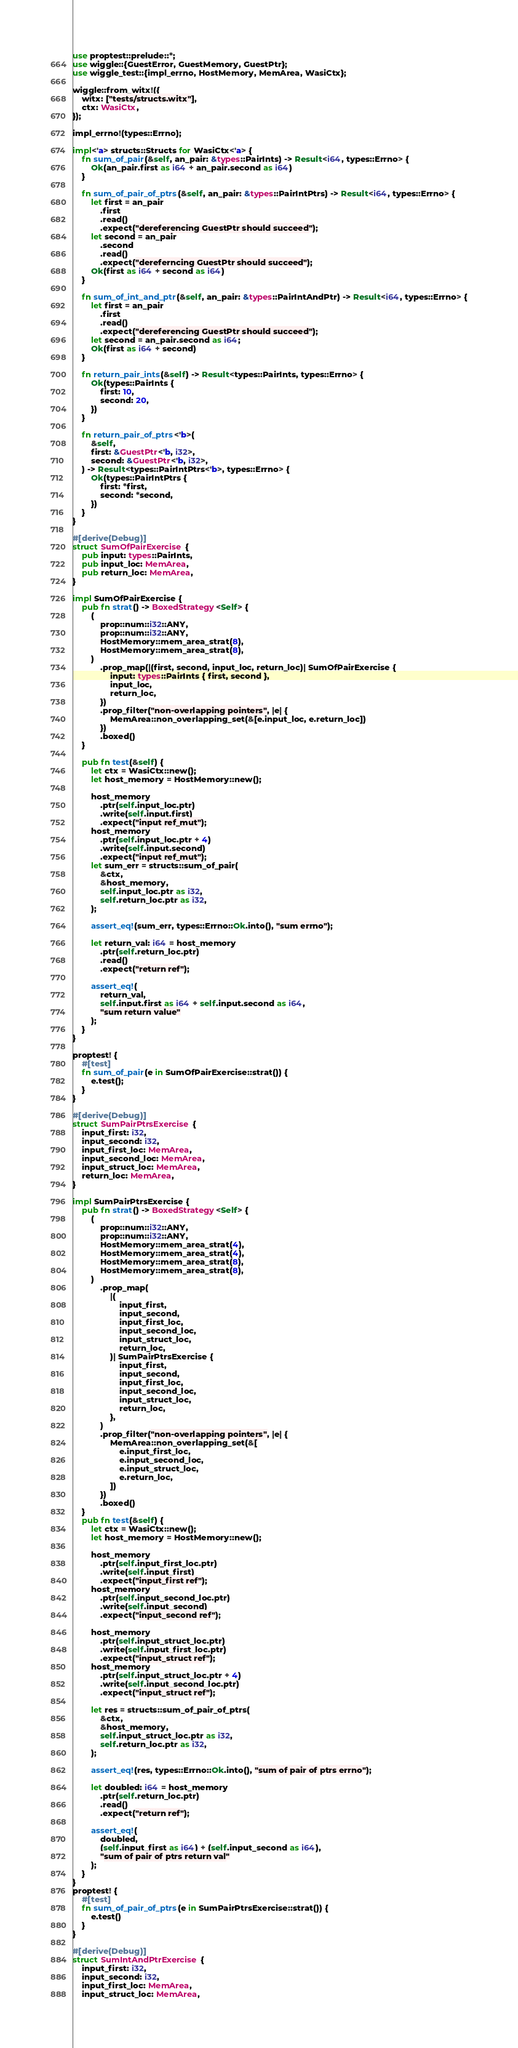Convert code to text. <code><loc_0><loc_0><loc_500><loc_500><_Rust_>use proptest::prelude::*;
use wiggle::{GuestError, GuestMemory, GuestPtr};
use wiggle_test::{impl_errno, HostMemory, MemArea, WasiCtx};

wiggle::from_witx!({
    witx: ["tests/structs.witx"],
    ctx: WasiCtx,
});

impl_errno!(types::Errno);

impl<'a> structs::Structs for WasiCtx<'a> {
    fn sum_of_pair(&self, an_pair: &types::PairInts) -> Result<i64, types::Errno> {
        Ok(an_pair.first as i64 + an_pair.second as i64)
    }

    fn sum_of_pair_of_ptrs(&self, an_pair: &types::PairIntPtrs) -> Result<i64, types::Errno> {
        let first = an_pair
            .first
            .read()
            .expect("dereferencing GuestPtr should succeed");
        let second = an_pair
            .second
            .read()
            .expect("dereferncing GuestPtr should succeed");
        Ok(first as i64 + second as i64)
    }

    fn sum_of_int_and_ptr(&self, an_pair: &types::PairIntAndPtr) -> Result<i64, types::Errno> {
        let first = an_pair
            .first
            .read()
            .expect("dereferencing GuestPtr should succeed");
        let second = an_pair.second as i64;
        Ok(first as i64 + second)
    }

    fn return_pair_ints(&self) -> Result<types::PairInts, types::Errno> {
        Ok(types::PairInts {
            first: 10,
            second: 20,
        })
    }

    fn return_pair_of_ptrs<'b>(
        &self,
        first: &GuestPtr<'b, i32>,
        second: &GuestPtr<'b, i32>,
    ) -> Result<types::PairIntPtrs<'b>, types::Errno> {
        Ok(types::PairIntPtrs {
            first: *first,
            second: *second,
        })
    }
}

#[derive(Debug)]
struct SumOfPairExercise {
    pub input: types::PairInts,
    pub input_loc: MemArea,
    pub return_loc: MemArea,
}

impl SumOfPairExercise {
    pub fn strat() -> BoxedStrategy<Self> {
        (
            prop::num::i32::ANY,
            prop::num::i32::ANY,
            HostMemory::mem_area_strat(8),
            HostMemory::mem_area_strat(8),
        )
            .prop_map(|(first, second, input_loc, return_loc)| SumOfPairExercise {
                input: types::PairInts { first, second },
                input_loc,
                return_loc,
            })
            .prop_filter("non-overlapping pointers", |e| {
                MemArea::non_overlapping_set(&[e.input_loc, e.return_loc])
            })
            .boxed()
    }

    pub fn test(&self) {
        let ctx = WasiCtx::new();
        let host_memory = HostMemory::new();

        host_memory
            .ptr(self.input_loc.ptr)
            .write(self.input.first)
            .expect("input ref_mut");
        host_memory
            .ptr(self.input_loc.ptr + 4)
            .write(self.input.second)
            .expect("input ref_mut");
        let sum_err = structs::sum_of_pair(
            &ctx,
            &host_memory,
            self.input_loc.ptr as i32,
            self.return_loc.ptr as i32,
        );

        assert_eq!(sum_err, types::Errno::Ok.into(), "sum errno");

        let return_val: i64 = host_memory
            .ptr(self.return_loc.ptr)
            .read()
            .expect("return ref");

        assert_eq!(
            return_val,
            self.input.first as i64 + self.input.second as i64,
            "sum return value"
        );
    }
}

proptest! {
    #[test]
    fn sum_of_pair(e in SumOfPairExercise::strat()) {
        e.test();
    }
}

#[derive(Debug)]
struct SumPairPtrsExercise {
    input_first: i32,
    input_second: i32,
    input_first_loc: MemArea,
    input_second_loc: MemArea,
    input_struct_loc: MemArea,
    return_loc: MemArea,
}

impl SumPairPtrsExercise {
    pub fn strat() -> BoxedStrategy<Self> {
        (
            prop::num::i32::ANY,
            prop::num::i32::ANY,
            HostMemory::mem_area_strat(4),
            HostMemory::mem_area_strat(4),
            HostMemory::mem_area_strat(8),
            HostMemory::mem_area_strat(8),
        )
            .prop_map(
                |(
                    input_first,
                    input_second,
                    input_first_loc,
                    input_second_loc,
                    input_struct_loc,
                    return_loc,
                )| SumPairPtrsExercise {
                    input_first,
                    input_second,
                    input_first_loc,
                    input_second_loc,
                    input_struct_loc,
                    return_loc,
                },
            )
            .prop_filter("non-overlapping pointers", |e| {
                MemArea::non_overlapping_set(&[
                    e.input_first_loc,
                    e.input_second_loc,
                    e.input_struct_loc,
                    e.return_loc,
                ])
            })
            .boxed()
    }
    pub fn test(&self) {
        let ctx = WasiCtx::new();
        let host_memory = HostMemory::new();

        host_memory
            .ptr(self.input_first_loc.ptr)
            .write(self.input_first)
            .expect("input_first ref");
        host_memory
            .ptr(self.input_second_loc.ptr)
            .write(self.input_second)
            .expect("input_second ref");

        host_memory
            .ptr(self.input_struct_loc.ptr)
            .write(self.input_first_loc.ptr)
            .expect("input_struct ref");
        host_memory
            .ptr(self.input_struct_loc.ptr + 4)
            .write(self.input_second_loc.ptr)
            .expect("input_struct ref");

        let res = structs::sum_of_pair_of_ptrs(
            &ctx,
            &host_memory,
            self.input_struct_loc.ptr as i32,
            self.return_loc.ptr as i32,
        );

        assert_eq!(res, types::Errno::Ok.into(), "sum of pair of ptrs errno");

        let doubled: i64 = host_memory
            .ptr(self.return_loc.ptr)
            .read()
            .expect("return ref");

        assert_eq!(
            doubled,
            (self.input_first as i64) + (self.input_second as i64),
            "sum of pair of ptrs return val"
        );
    }
}
proptest! {
    #[test]
    fn sum_of_pair_of_ptrs(e in SumPairPtrsExercise::strat()) {
        e.test()
    }
}

#[derive(Debug)]
struct SumIntAndPtrExercise {
    input_first: i32,
    input_second: i32,
    input_first_loc: MemArea,
    input_struct_loc: MemArea,</code> 